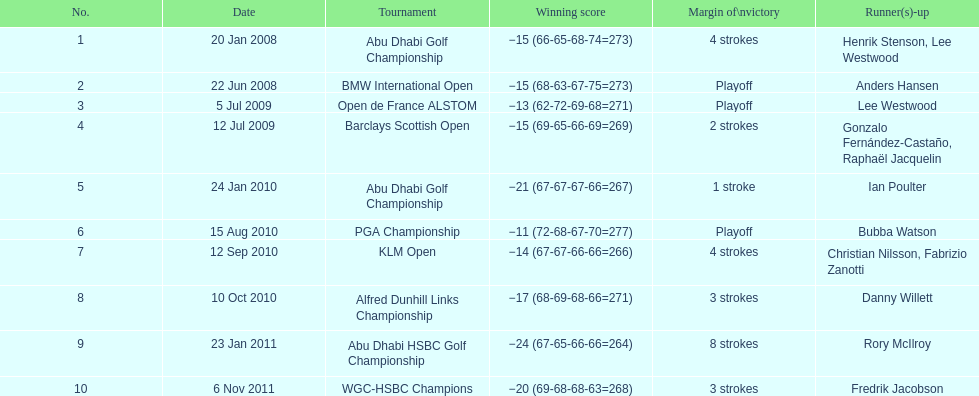What was the duration between the playoff win at the bmw international open and the 4-stroke triumph at the klm open? 2 years. 